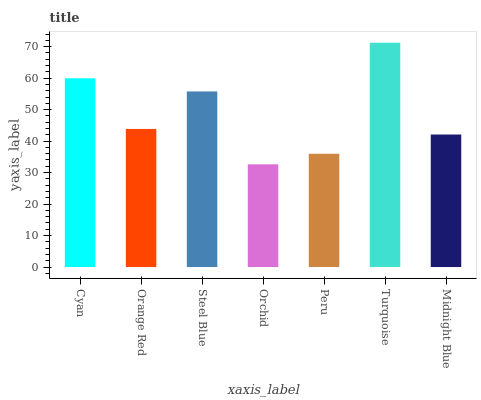Is Orange Red the minimum?
Answer yes or no. No. Is Orange Red the maximum?
Answer yes or no. No. Is Cyan greater than Orange Red?
Answer yes or no. Yes. Is Orange Red less than Cyan?
Answer yes or no. Yes. Is Orange Red greater than Cyan?
Answer yes or no. No. Is Cyan less than Orange Red?
Answer yes or no. No. Is Orange Red the high median?
Answer yes or no. Yes. Is Orange Red the low median?
Answer yes or no. Yes. Is Steel Blue the high median?
Answer yes or no. No. Is Steel Blue the low median?
Answer yes or no. No. 